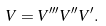Convert formula to latex. <formula><loc_0><loc_0><loc_500><loc_500>V = V ^ { \prime \prime \prime } V ^ { \prime \prime } V ^ { \prime } .</formula> 